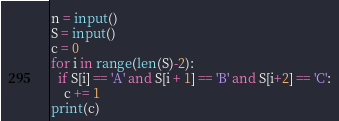Convert code to text. <code><loc_0><loc_0><loc_500><loc_500><_Python_>n = input()
S = input()
c = 0
for i in range(len(S)-2):
  if S[i] == 'A' and S[i + 1] == 'B' and S[i+2] == 'C':
    c += 1
print(c)</code> 